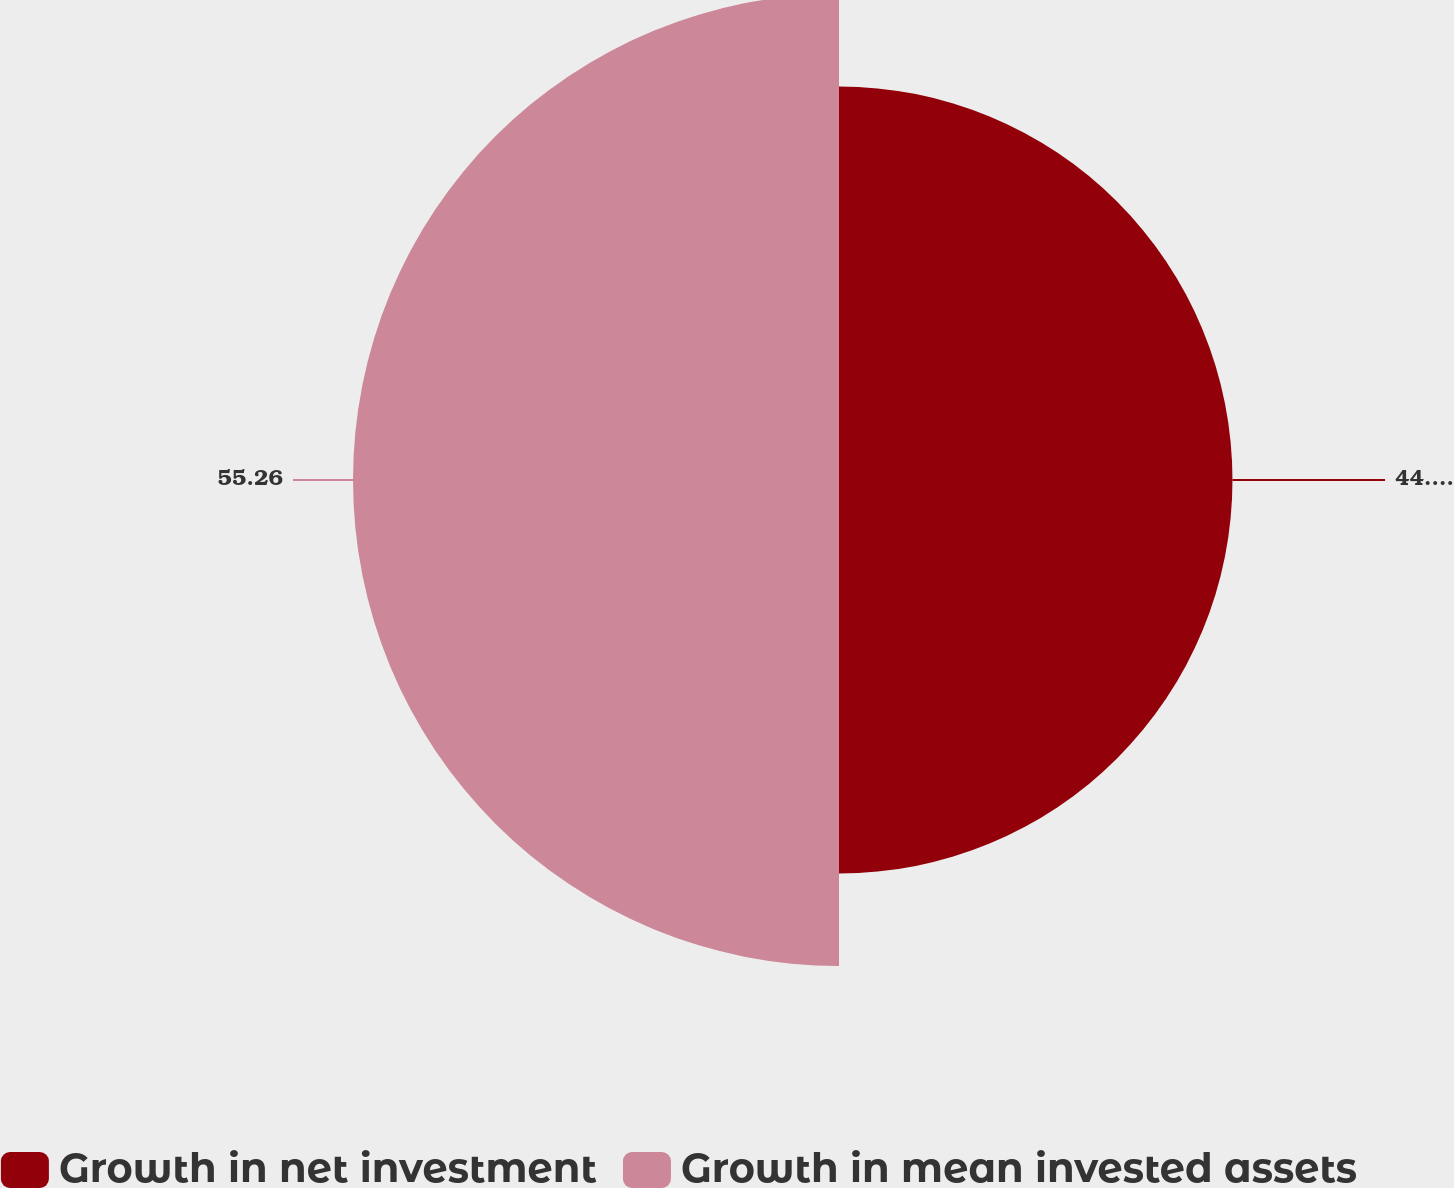Convert chart. <chart><loc_0><loc_0><loc_500><loc_500><pie_chart><fcel>Growth in net investment<fcel>Growth in mean invested assets<nl><fcel>44.74%<fcel>55.26%<nl></chart> 